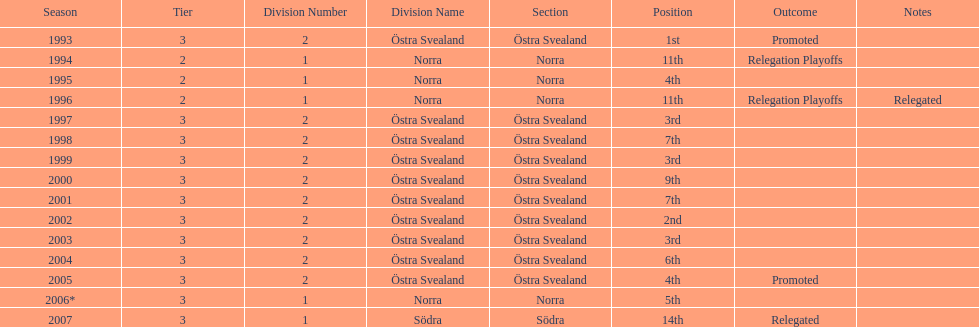How many times is division 2 listed as the division? 10. 